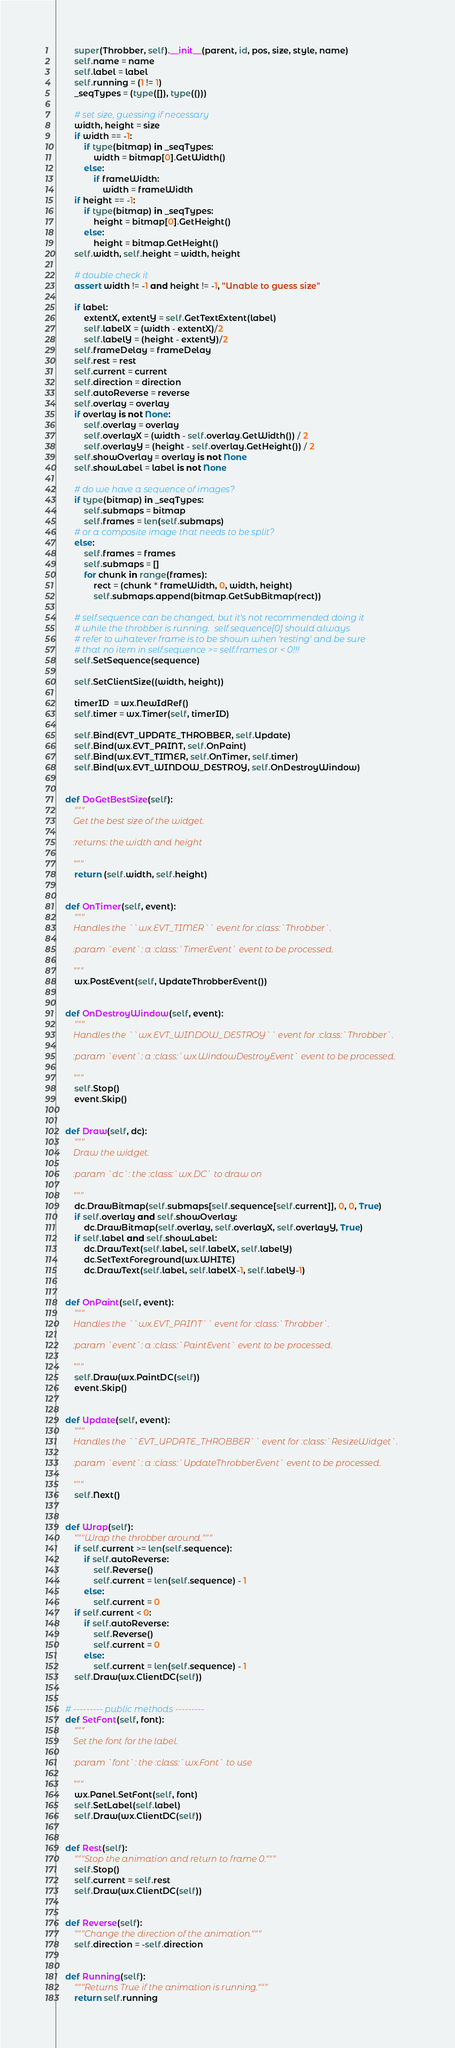Convert code to text. <code><loc_0><loc_0><loc_500><loc_500><_Python_>        super(Throbber, self).__init__(parent, id, pos, size, style, name)
        self.name = name
        self.label = label
        self.running = (1 != 1)
        _seqTypes = (type([]), type(()))

        # set size, guessing if necessary
        width, height = size
        if width == -1:
            if type(bitmap) in _seqTypes:
                width = bitmap[0].GetWidth()
            else:
                if frameWidth:
                    width = frameWidth
        if height == -1:
            if type(bitmap) in _seqTypes:
                height = bitmap[0].GetHeight()
            else:
                height = bitmap.GetHeight()
        self.width, self.height = width, height

        # double check it
        assert width != -1 and height != -1, "Unable to guess size"

        if label:
            extentX, extentY = self.GetTextExtent(label)
            self.labelX = (width - extentX)/2
            self.labelY = (height - extentY)/2
        self.frameDelay = frameDelay
        self.rest = rest
        self.current = current
        self.direction = direction
        self.autoReverse = reverse
        self.overlay = overlay
        if overlay is not None:
            self.overlay = overlay
            self.overlayX = (width - self.overlay.GetWidth()) / 2
            self.overlayY = (height - self.overlay.GetHeight()) / 2
        self.showOverlay = overlay is not None
        self.showLabel = label is not None

        # do we have a sequence of images?
        if type(bitmap) in _seqTypes:
            self.submaps = bitmap
            self.frames = len(self.submaps)
        # or a composite image that needs to be split?
        else:
            self.frames = frames
            self.submaps = []
            for chunk in range(frames):
                rect = (chunk * frameWidth, 0, width, height)
                self.submaps.append(bitmap.GetSubBitmap(rect))

        # self.sequence can be changed, but it's not recommended doing it
        # while the throbber is running.  self.sequence[0] should always
        # refer to whatever frame is to be shown when 'resting' and be sure
        # that no item in self.sequence >= self.frames or < 0!!!
        self.SetSequence(sequence)

        self.SetClientSize((width, height))

        timerID  = wx.NewIdRef()
        self.timer = wx.Timer(self, timerID)

        self.Bind(EVT_UPDATE_THROBBER, self.Update)
        self.Bind(wx.EVT_PAINT, self.OnPaint)
        self.Bind(wx.EVT_TIMER, self.OnTimer, self.timer)
        self.Bind(wx.EVT_WINDOW_DESTROY, self.OnDestroyWindow)


    def DoGetBestSize(self):
        """
        Get the best size of the widget.

        :returns: the width and height

        """
        return (self.width, self.height)


    def OnTimer(self, event):
        """
        Handles the ``wx.EVT_TIMER`` event for :class:`Throbber`.

        :param `event`: a :class:`TimerEvent` event to be processed.

        """
        wx.PostEvent(self, UpdateThrobberEvent())


    def OnDestroyWindow(self, event):
        """
        Handles the ``wx.EVT_WINDOW_DESTROY`` event for :class:`Throbber`.

        :param `event`: a :class:`wx.WindowDestroyEvent` event to be processed.

        """
        self.Stop()
        event.Skip()


    def Draw(self, dc):
        """
        Draw the widget.

        :param `dc`: the :class:`wx.DC` to draw on

        """
        dc.DrawBitmap(self.submaps[self.sequence[self.current]], 0, 0, True)
        if self.overlay and self.showOverlay:
            dc.DrawBitmap(self.overlay, self.overlayX, self.overlayY, True)
        if self.label and self.showLabel:
            dc.DrawText(self.label, self.labelX, self.labelY)
            dc.SetTextForeground(wx.WHITE)
            dc.DrawText(self.label, self.labelX-1, self.labelY-1)


    def OnPaint(self, event):
        """
        Handles the ``wx.EVT_PAINT`` event for :class:`Throbber`.

        :param `event`: a :class:`PaintEvent` event to be processed.

        """
        self.Draw(wx.PaintDC(self))
        event.Skip()


    def Update(self, event):
        """
        Handles the ``EVT_UPDATE_THROBBER`` event for :class:`ResizeWidget`.

        :param `event`: a :class:`UpdateThrobberEvent` event to be processed.

        """
        self.Next()


    def Wrap(self):
        """Wrap the throbber around."""
        if self.current >= len(self.sequence):
            if self.autoReverse:
                self.Reverse()
                self.current = len(self.sequence) - 1
            else:
                self.current = 0
        if self.current < 0:
            if self.autoReverse:
                self.Reverse()
                self.current = 0
            else:
                self.current = len(self.sequence) - 1
        self.Draw(wx.ClientDC(self))


    # --------- public methods ---------
    def SetFont(self, font):
        """
        Set the font for the label.

        :param `font`: the :class:`wx.Font` to use

        """
        wx.Panel.SetFont(self, font)
        self.SetLabel(self.label)
        self.Draw(wx.ClientDC(self))


    def Rest(self):
        """Stop the animation and return to frame 0."""
        self.Stop()
        self.current = self.rest
        self.Draw(wx.ClientDC(self))


    def Reverse(self):
        """Change the direction of the animation."""
        self.direction = -self.direction


    def Running(self):
        """Returns True if the animation is running."""
        return self.running

</code> 